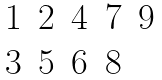Convert formula to latex. <formula><loc_0><loc_0><loc_500><loc_500>\begin{matrix} 1 & 2 & 4 & 7 & 9 \\ 3 & 5 & 6 & 8 & \\ \end{matrix}</formula> 